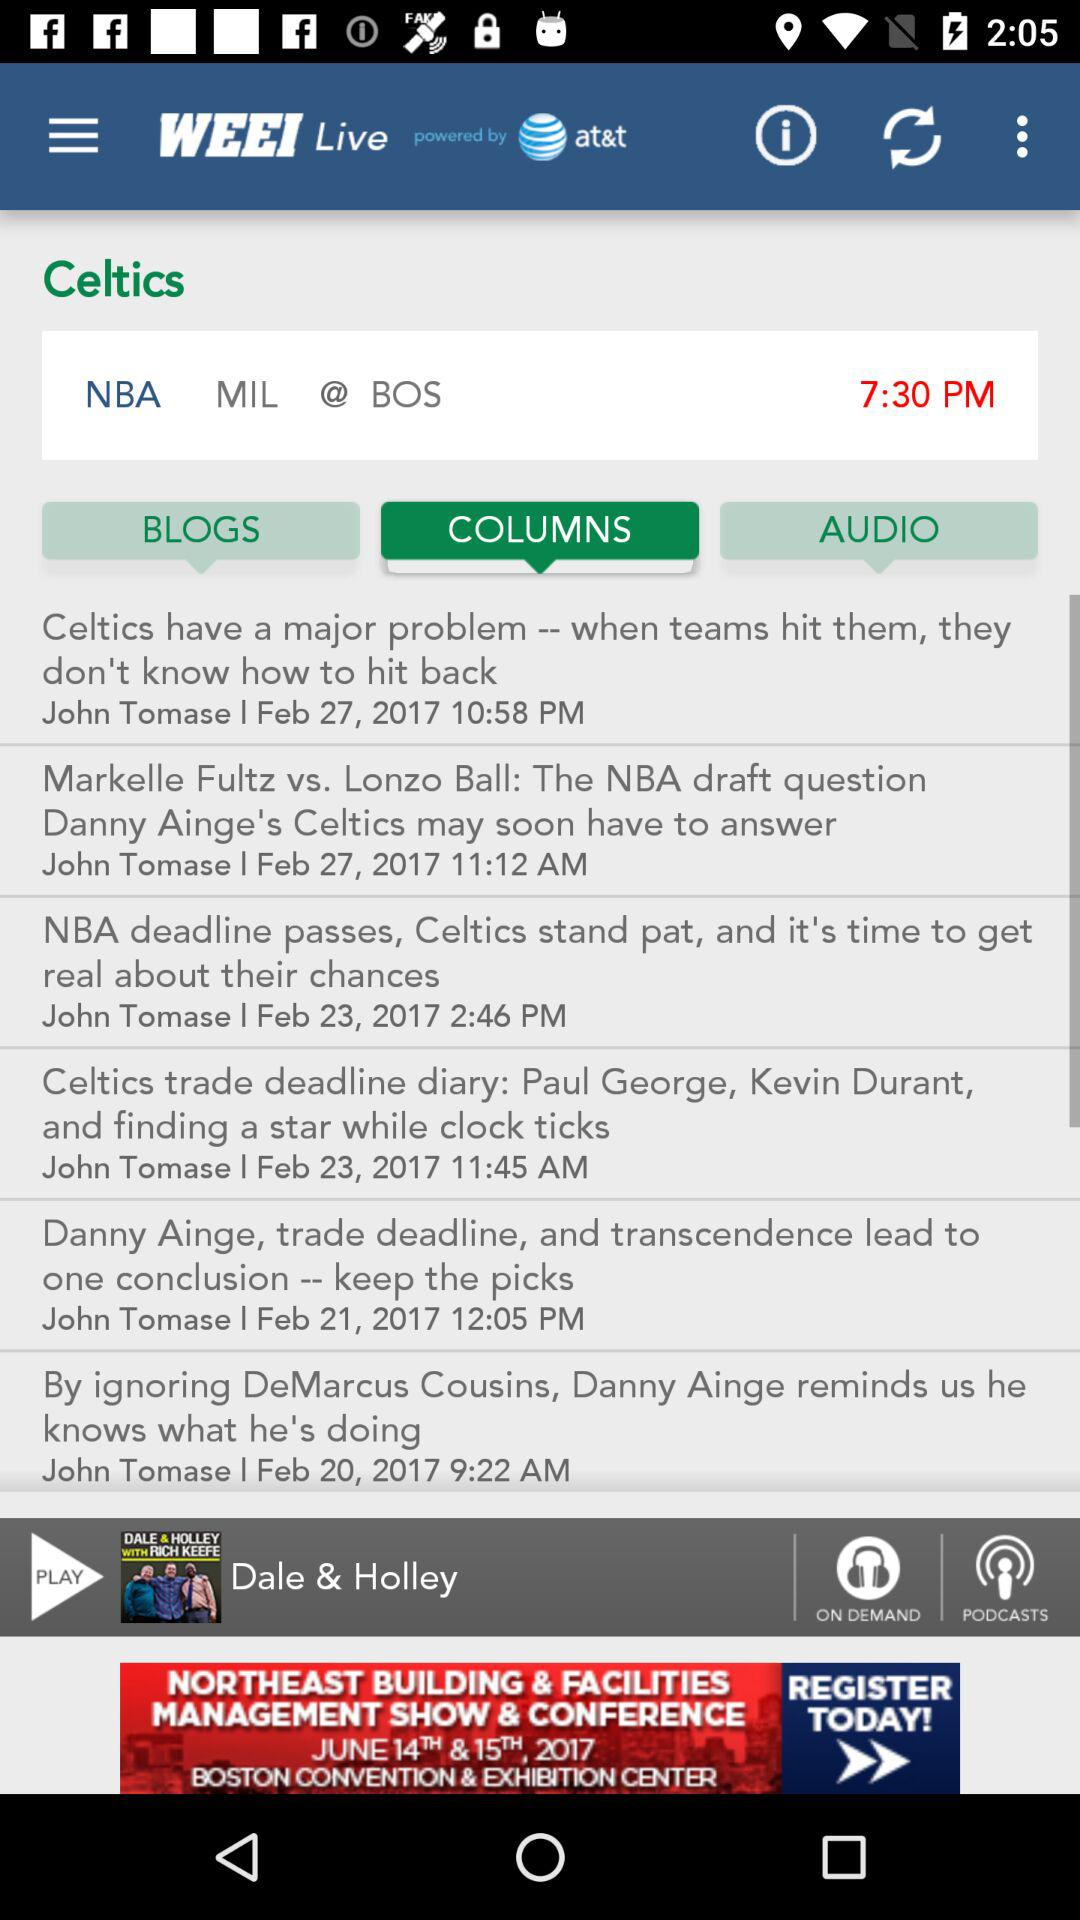What is the name of the application? The name of the application is "WEEI Live". 